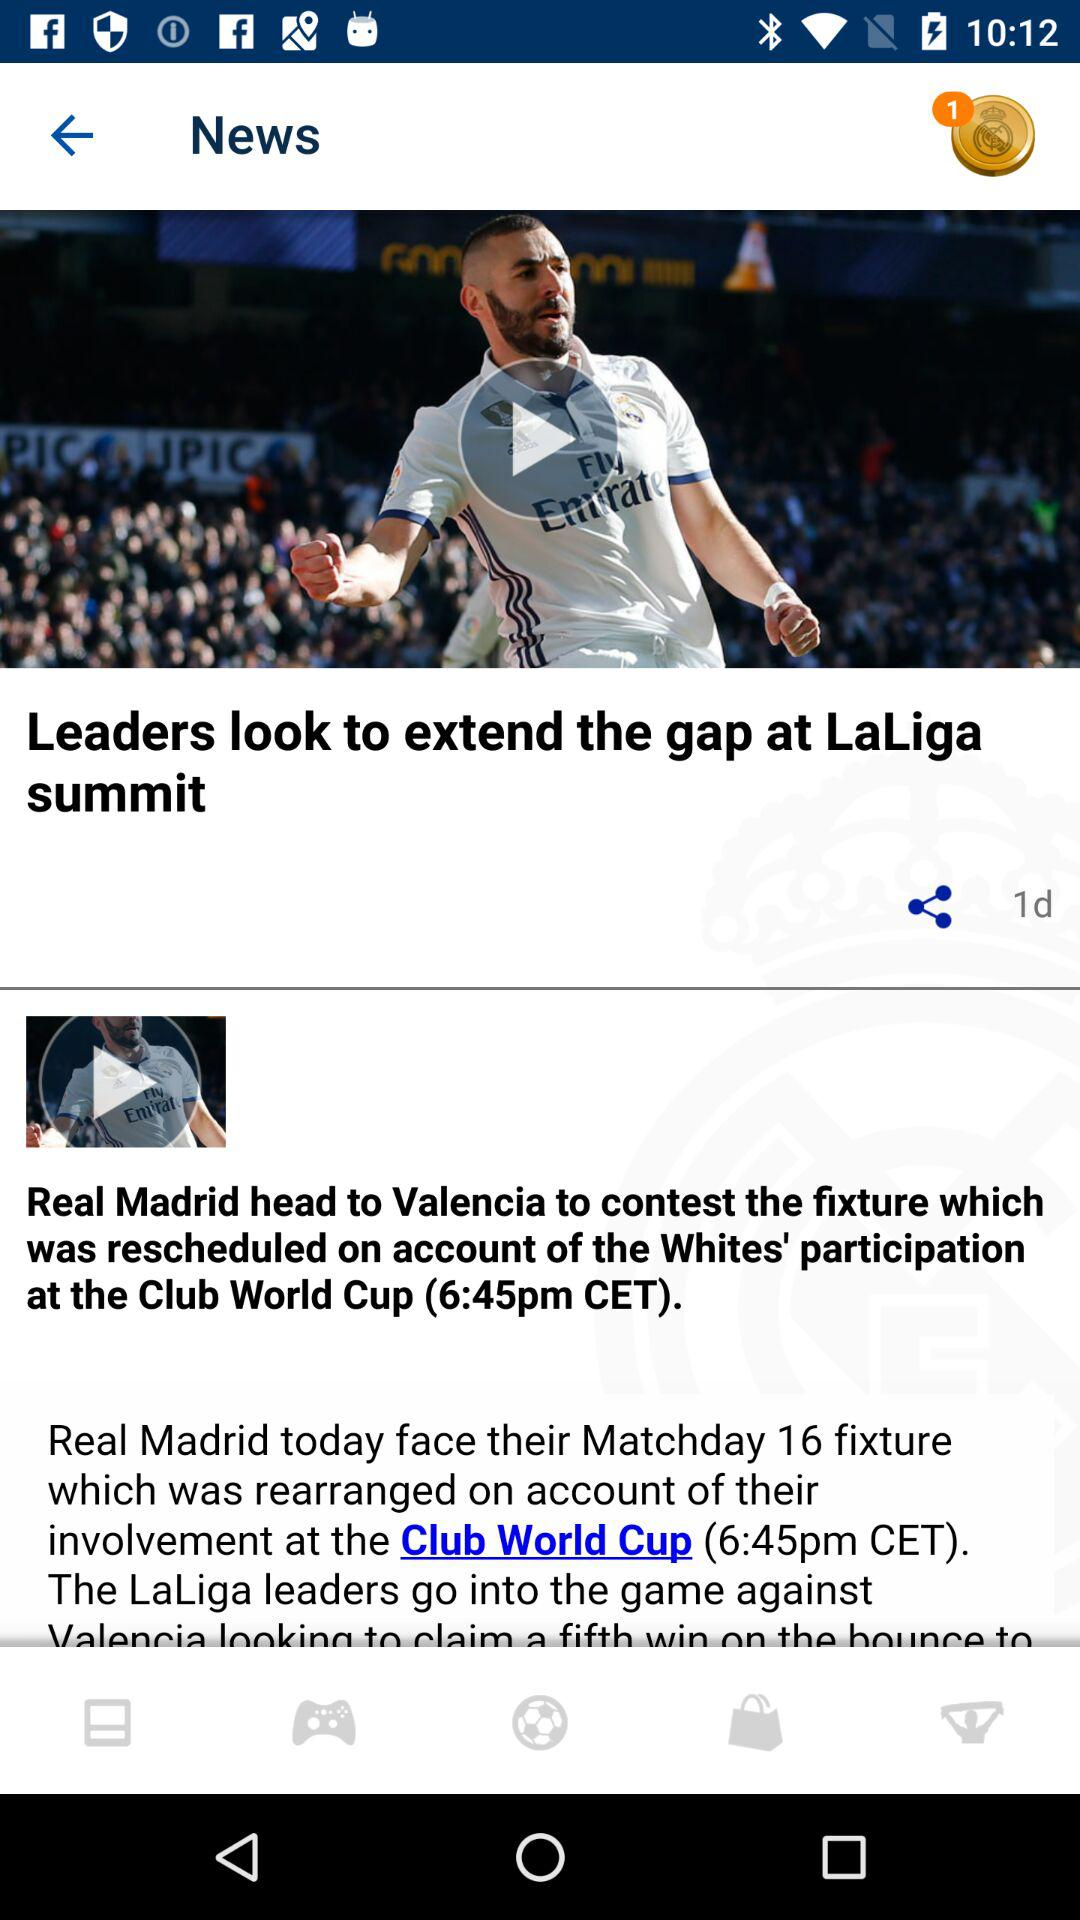Through which applications can this be shared?
When the provided information is insufficient, respond with <no answer>. <no answer> 